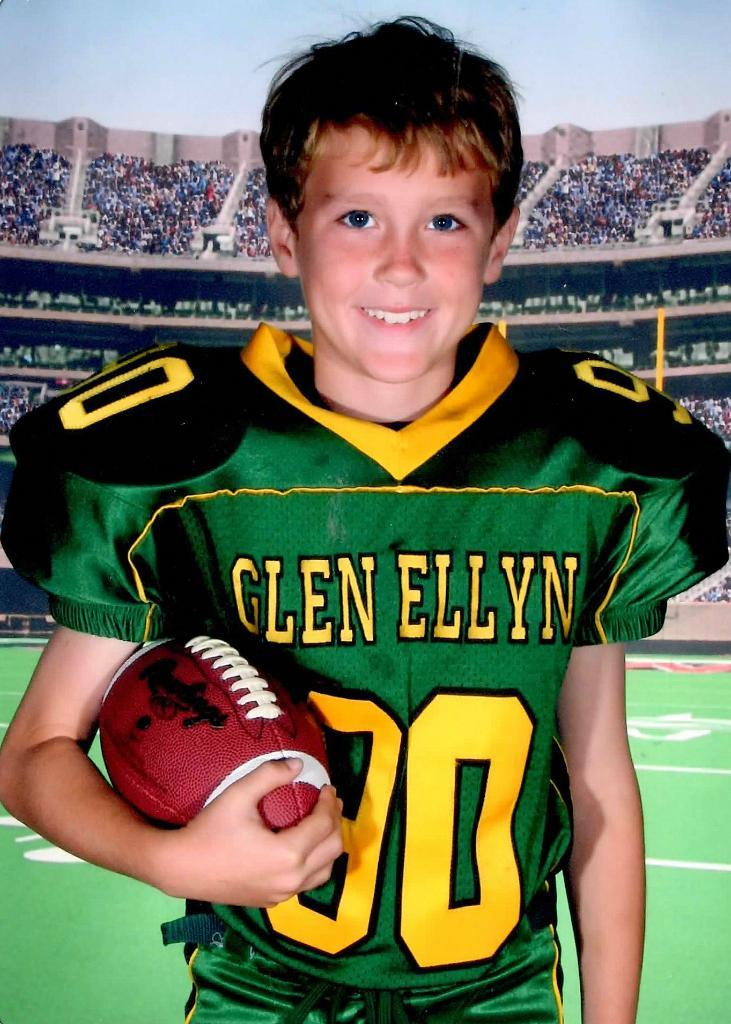<image>
Provide a brief description of the given image. a football player from the team Glen Ellyn 